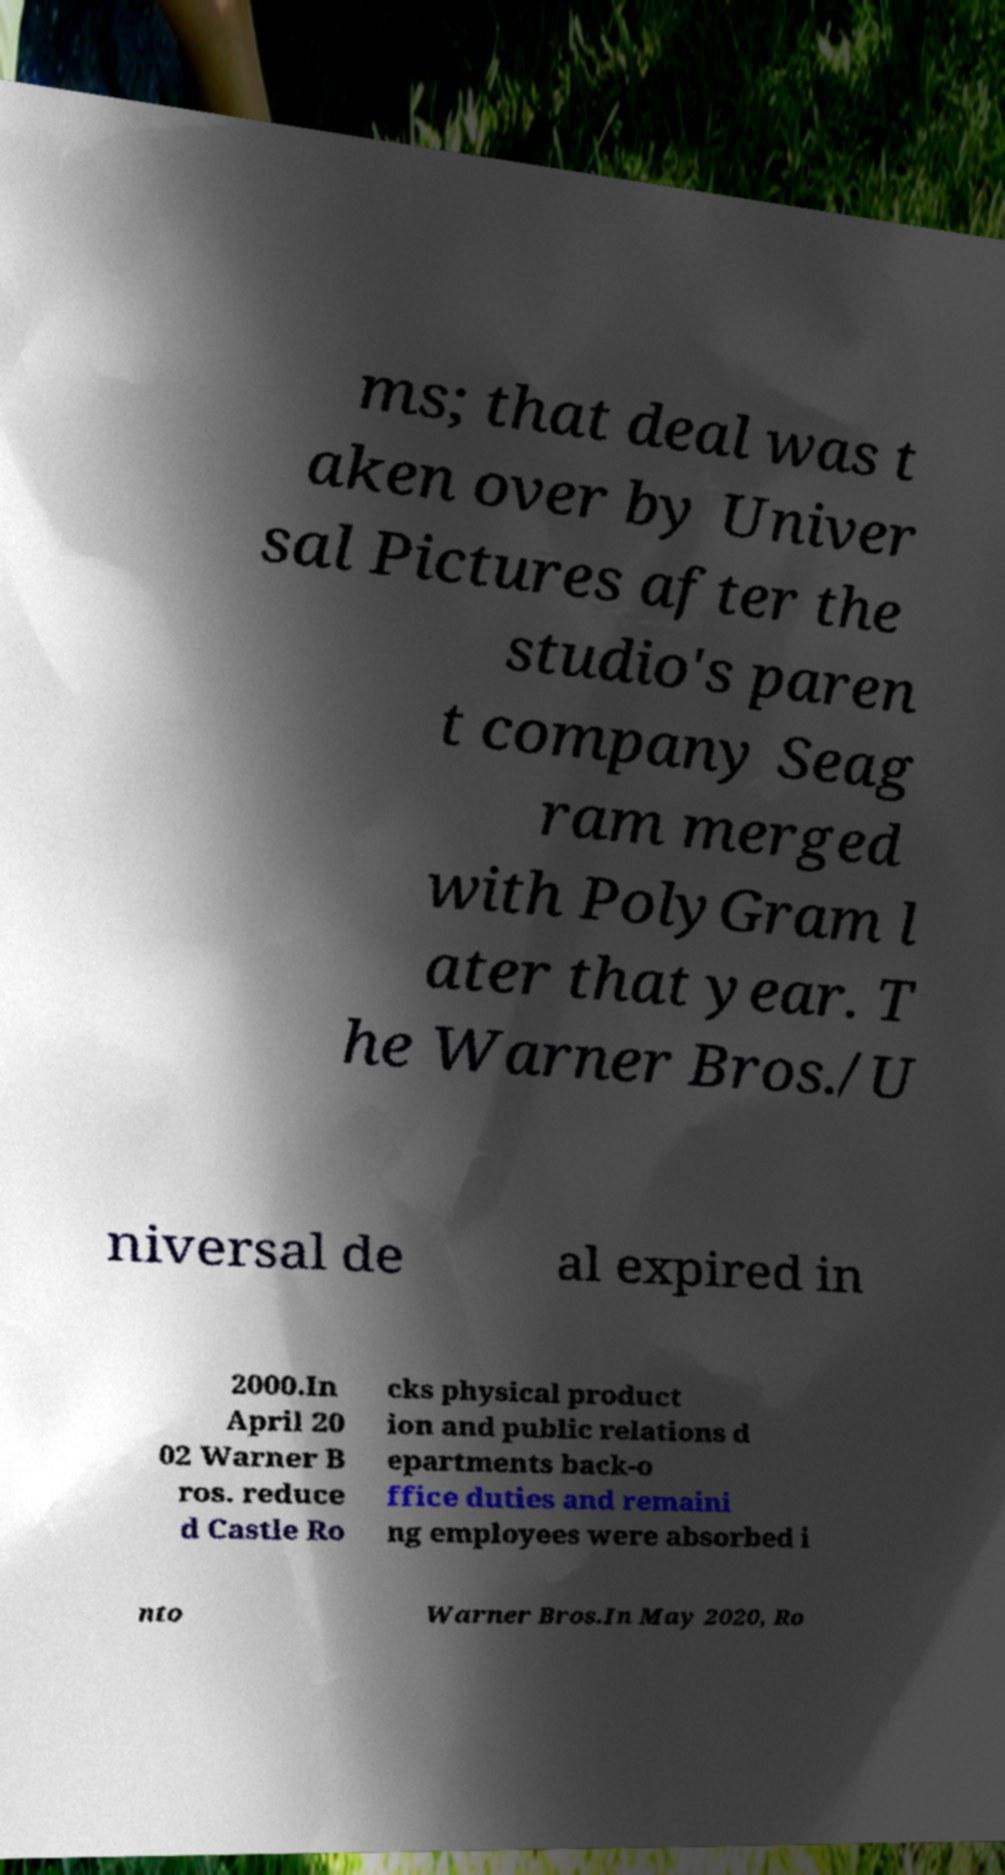Can you read and provide the text displayed in the image?This photo seems to have some interesting text. Can you extract and type it out for me? ms; that deal was t aken over by Univer sal Pictures after the studio's paren t company Seag ram merged with PolyGram l ater that year. T he Warner Bros./U niversal de al expired in 2000.In April 20 02 Warner B ros. reduce d Castle Ro cks physical product ion and public relations d epartments back-o ffice duties and remaini ng employees were absorbed i nto Warner Bros.In May 2020, Ro 